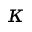<formula> <loc_0><loc_0><loc_500><loc_500>\kappa</formula> 